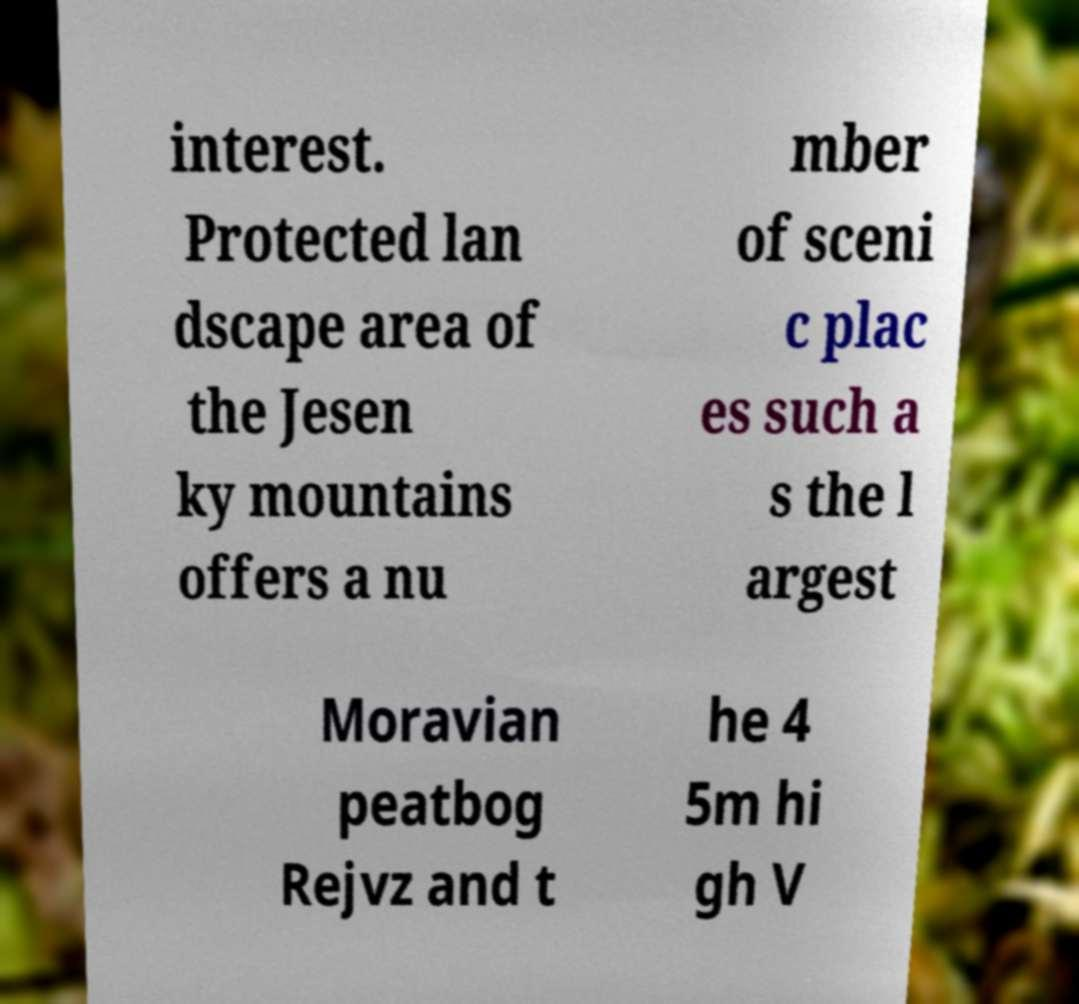Could you assist in decoding the text presented in this image and type it out clearly? interest. Protected lan dscape area of the Jesen ky mountains offers a nu mber of sceni c plac es such a s the l argest Moravian peatbog Rejvz and t he 4 5m hi gh V 